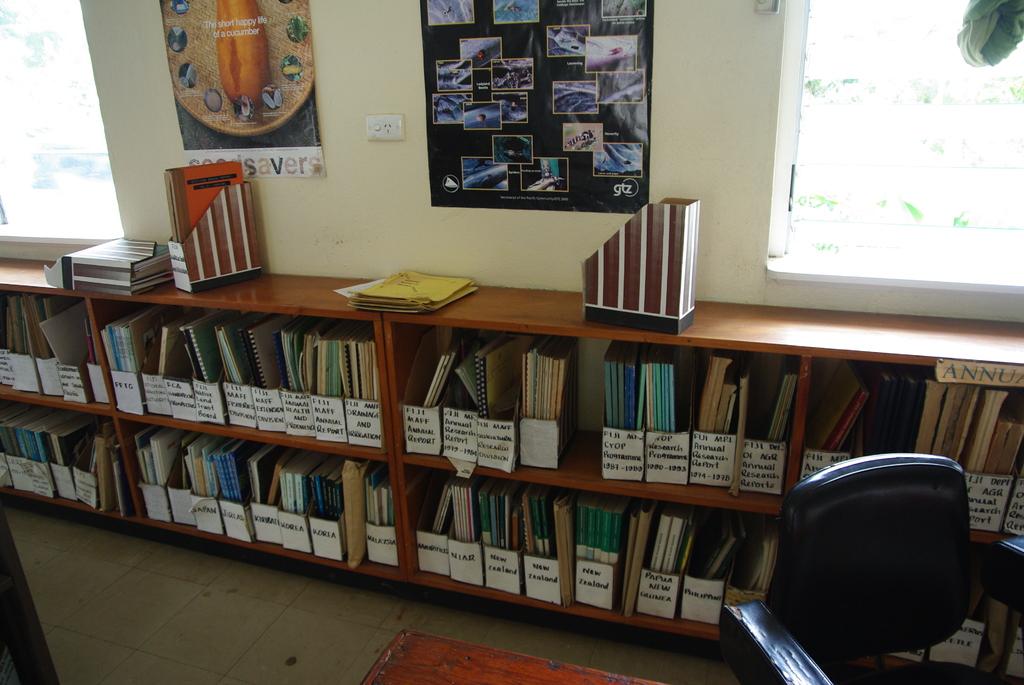What vegetable is named on the poster?
Your answer should be very brief. Cucumber. 